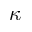Convert formula to latex. <formula><loc_0><loc_0><loc_500><loc_500>\kappa</formula> 